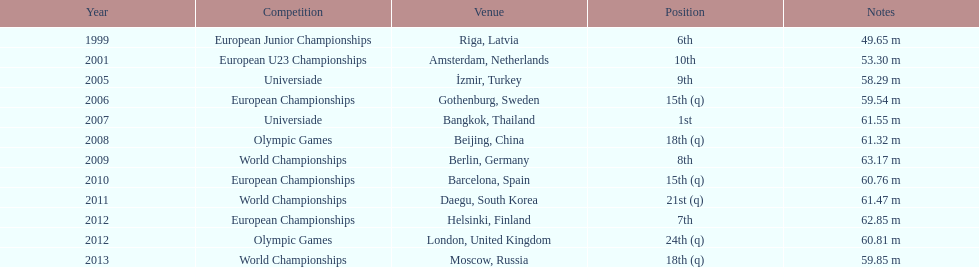What was mayer's best result: i.e his longest throw? 63.17 m. 